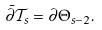Convert formula to latex. <formula><loc_0><loc_0><loc_500><loc_500>\bar { \partial } \mathcal { T } _ { s } = \partial \Theta _ { s - 2 } .</formula> 